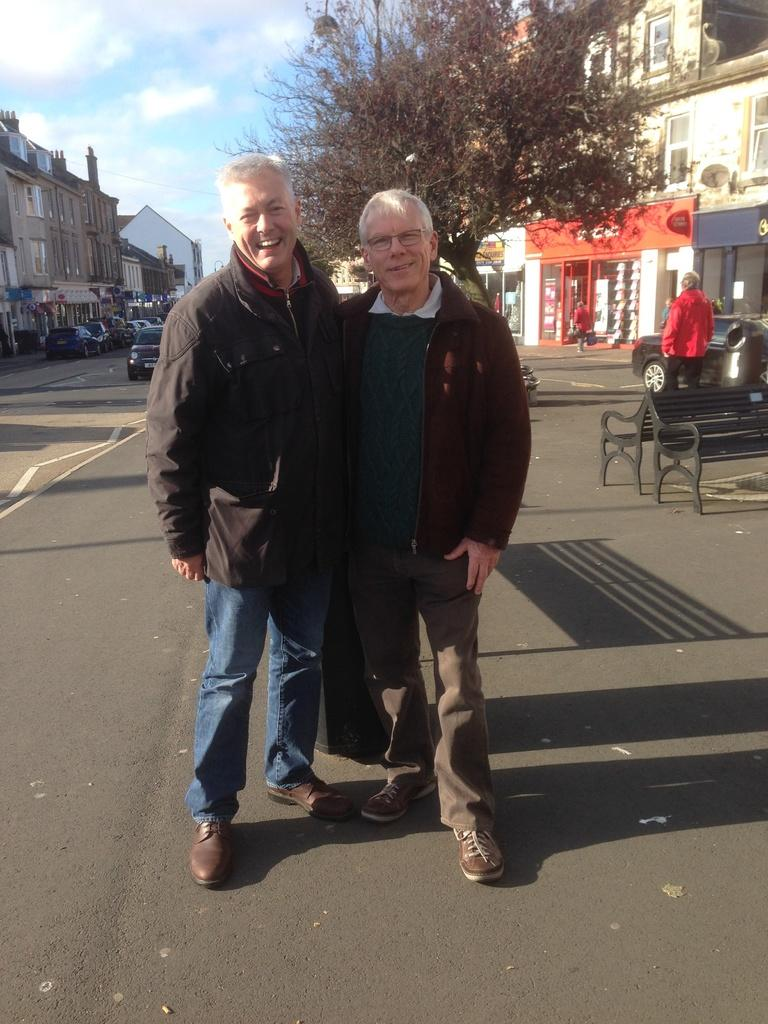How many people are in the image? There are two old men in the image. What are the men wearing? The men are wearing jackets. Where are the men standing? The men are standing on the road. What can be seen on either side of the road? There are buildings on either side of the road. What type of vegetation is near the buildings? Trees are present near the buildings. What else can be seen in front of the buildings? Vehicles are in front of the buildings. How many deer can be seen in the image? There are no deer present in the image. What type of houses are visible in the image? The image does not show any houses; it features buildings and trees. 